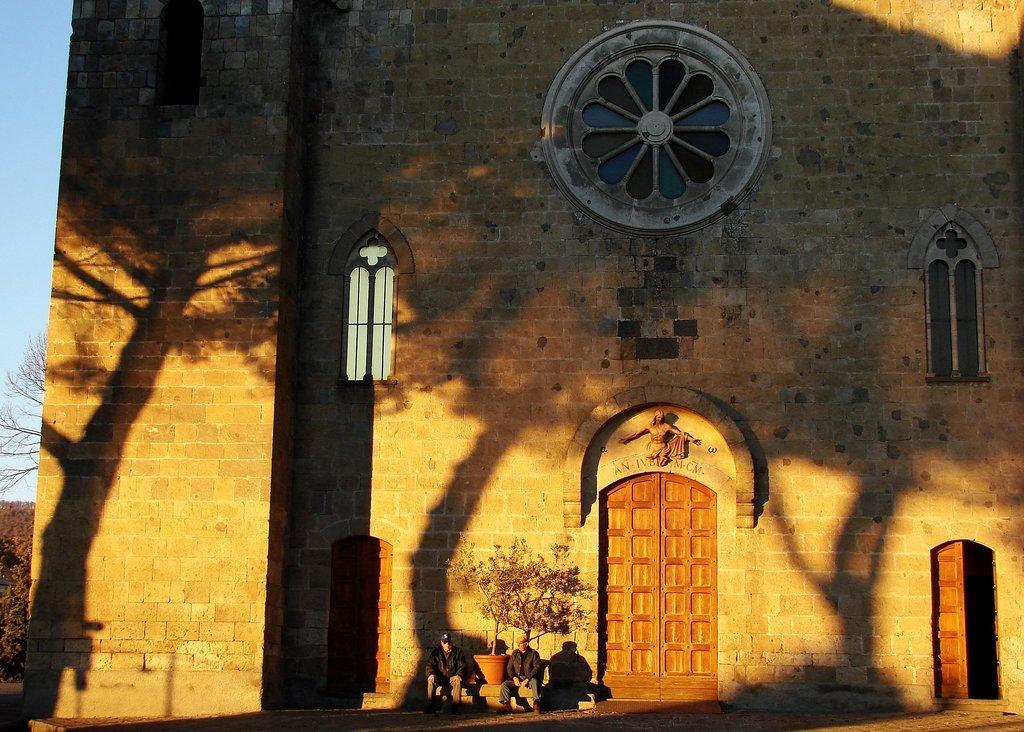How would you summarize this image in a sentence or two? In this picture we can see people sitting on a bench beside a pot with green leaves. Here we can see a brick wall with doors and windows. On the wall we can see shadows of trees and poles. The sky is bright. 